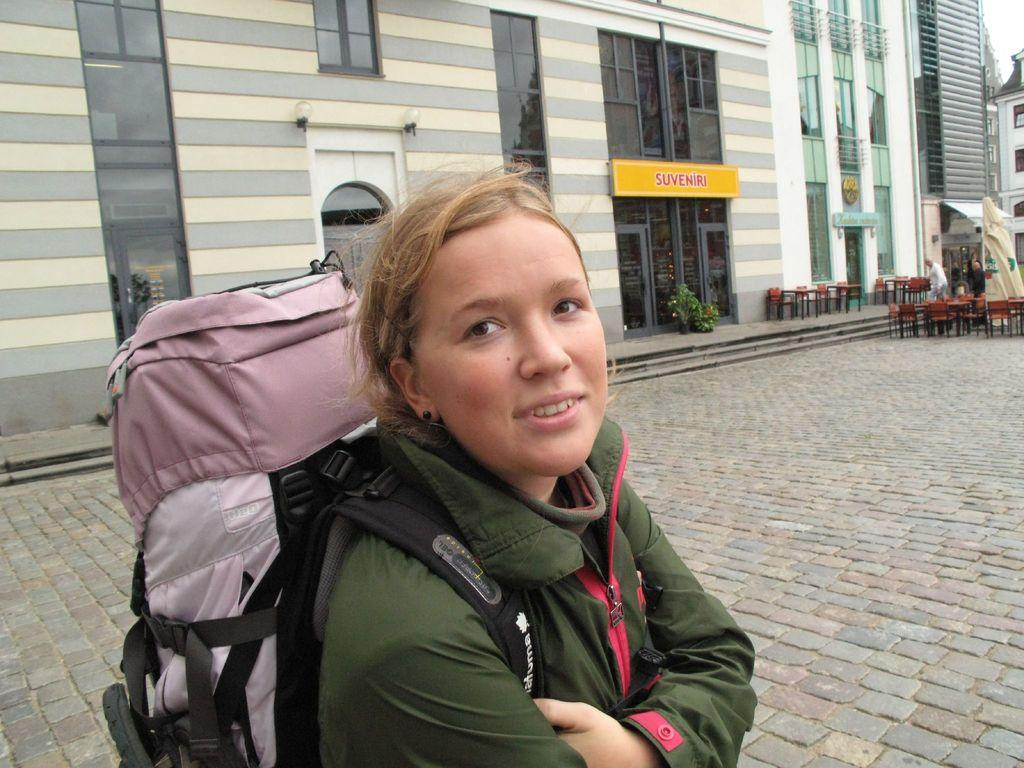Who is the main subject in the image? There is a woman in the image. What is the woman doing in the image? The woman is posing for the camera. What is the woman wearing in the image? The woman is wearing a backpack. What type of sack can be seen bursting in the image? There is no sack present in the image, let alone one that is bursting. 